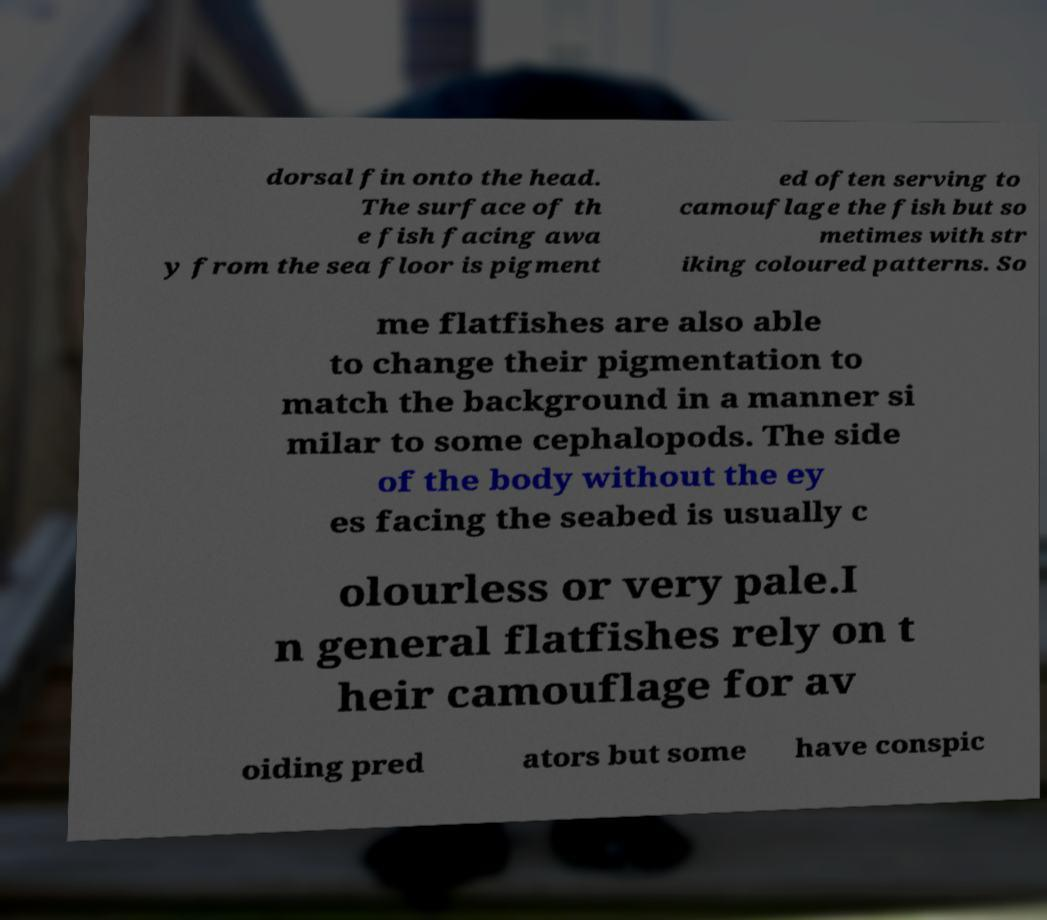Please read and relay the text visible in this image. What does it say? dorsal fin onto the head. The surface of th e fish facing awa y from the sea floor is pigment ed often serving to camouflage the fish but so metimes with str iking coloured patterns. So me flatfishes are also able to change their pigmentation to match the background in a manner si milar to some cephalopods. The side of the body without the ey es facing the seabed is usually c olourless or very pale.I n general flatfishes rely on t heir camouflage for av oiding pred ators but some have conspic 